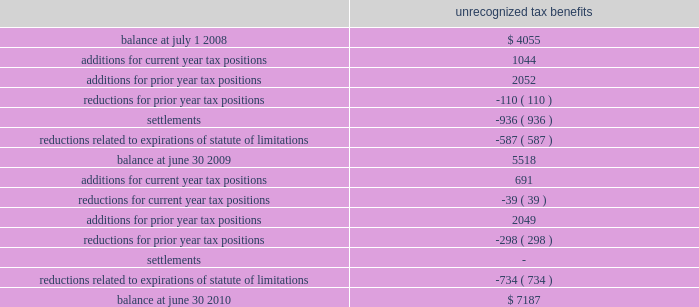48 2022 2010 annual report as part of the acquisition of gfsi , we acquired gross net operating loss ( 201cnol 201d ) carry forwards of $ 64431 ; of which , only $ 34592 are expected to be utilized due to the application of irc section 382 .
Separately , as of june 30 , 2010 , we had state nol carry forwards of $ 838 .
These losses have varying expiration dates , ranging from 2012 to 2029 .
Based on state tax rules which restrict our usage of these losses , we believe it is more likely than not that $ 306 of these losses will expire unutilized .
Accordingly , a valuation allowance of $ 306 has been recorded against these assets as of june 30 , 2010 .
The company paid income taxes of $ 42116 , $ 62965 , and $ 51709 in 2010 , 2009 , and 2008 , respectively .
At june 30 , 2009 , the company had $ 5518 of unrecognized tax benefits .
At june 30 , 2010 , the company had $ 7187 of unrecognized tax benefits , of which , $ 4989 , if recognized , would affect our effective tax rate .
We had accrued interest and penalties of $ 890 and $ 732 related to uncertain tax positions at june 30 , 2010 and 2009 , respectively .
A reconciliation of the unrecognized tax benefits for the years ended june 30 , 2010 and 2009 follows : unrecognized tax benefits .
During the fiscal year ended june 30 , 2010 , the internal revenue service commenced an examination of the company 2019s u.s .
Federal income tax returns for fiscal years ended june 2008 through 2009 .
The u.s .
Federal and state income tax returns for june 30 , 2007 and all subsequent years still remain subject to examination as of june 30 , 2010 under statute of limitations rules .
We anticipate potential changes resulting from the expiration of statutes of limitations of up to $ 965 could reduce the unrecognized tax benefits balance within twelve months of june 30 , note 8 : industry and supplier concentrations the company sells its products to banks , credit unions , and financial institutions throughout the united states and generally does not require collateral .
All billings to customers are due 30 days from date of billing .
Reserves ( which are insignificant at june 30 , 2010 , 2009 and 2008 ) are maintained for potential credit losses .
In addition , the company purchases most of its computer hardware and related maintenance for resale in relation to installation of jha software systems from two suppliers .
There are a limited number of hardware suppliers for these required items .
If these relationships were terminated , it could have a significant negative impact on the future operations of the company .
Note 9 : stock based compensation plans the company previously issued options to employees under the 1996 stock option plan ( 201c1996 sop 201d ) and currently issues options to outside directors under the 2005 non-qualified stock option plan ( 201c2005 nsop 201d ) .
1996 sop the 1996 sop was adopted by the company on october 29 , 1996 , for its employees .
Terms and vesting periods .
If the companies accounting policy were to include accrued interest and penalties in utp , what would the balance be as of at june 30 2009? 
Computations: (5518 + 732)
Answer: 6250.0. 